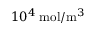<formula> <loc_0><loc_0><loc_500><loc_500>1 0 ^ { 4 } \, m o l / m ^ { 3 }</formula> 